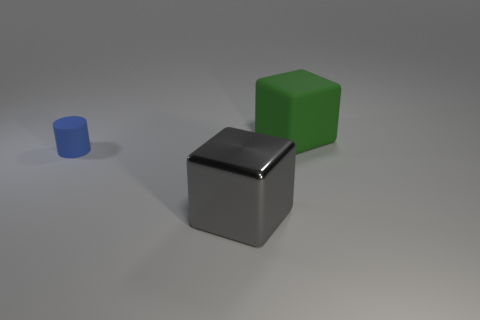Is there any other thing that has the same color as the large matte cube?
Offer a terse response. No. Are there more things that are in front of the large matte cube than tiny blue things?
Your response must be concise. Yes. Do the green object and the blue matte thing have the same size?
Keep it short and to the point. No. What is the material of the other green object that is the same shape as the shiny object?
Your answer should be compact. Rubber. Is there any other thing that is the same material as the small thing?
Give a very brief answer. Yes. How many yellow things are tiny things or big rubber cubes?
Your answer should be very brief. 0. What is the material of the cube behind the tiny blue thing?
Provide a succinct answer. Rubber. Is the number of gray metallic things greater than the number of big red metal cubes?
Keep it short and to the point. Yes. There is a object left of the gray shiny cube; is its shape the same as the shiny object?
Ensure brevity in your answer.  No. What number of objects are both behind the blue thing and to the left of the large green block?
Make the answer very short. 0. 